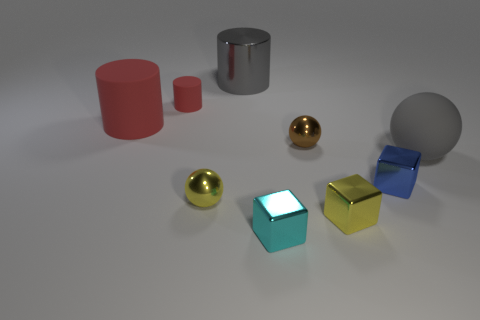Could you infer the likely purpose of this assortment of objects? The assortment of objects seems to be arranged for either a display or an exercise in visualization, rather than for practical use. Their differing shapes, colors, and textures may serve an educational purpose, such as in a study of light and shadow, or for a demonstration of rendering techniques in computer graphics. 